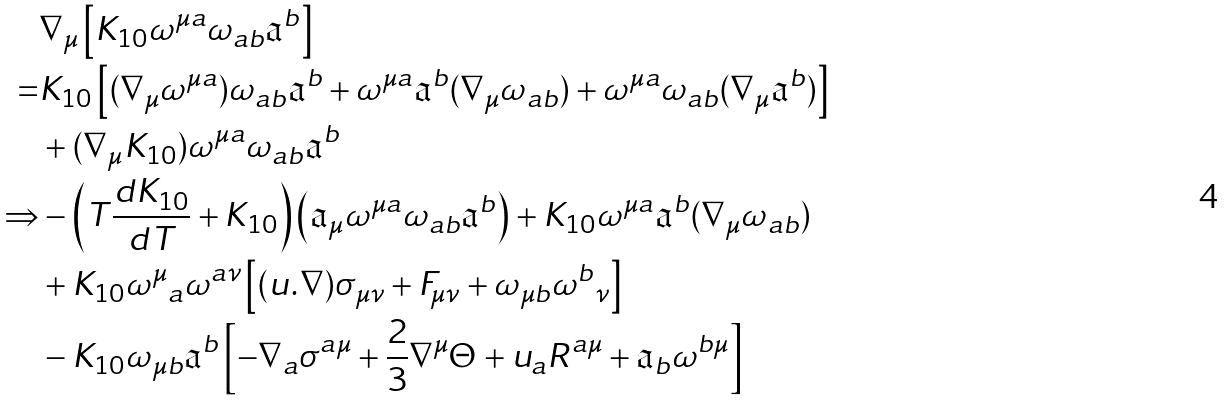<formula> <loc_0><loc_0><loc_500><loc_500>& \nabla _ { \mu } \left [ K _ { 1 0 } \omega ^ { \mu a } \omega _ { a b } { \mathfrak a } ^ { b } \right ] \\ = & K _ { 1 0 } \left [ ( \nabla _ { \mu } \omega ^ { \mu a } ) \omega _ { a b } { \mathfrak a } ^ { b } + \omega ^ { \mu a } { \mathfrak a } ^ { b } ( \nabla _ { \mu } \omega _ { a b } ) + \omega ^ { \mu a } \omega _ { a b } ( \nabla _ { \mu } { \mathfrak a } ^ { b } ) \right ] \\ & + ( \nabla _ { \mu } K _ { 1 0 } ) \omega ^ { \mu a } \omega _ { a b } { \mathfrak a } ^ { b } \\ \Rightarrow & - \left ( T \frac { d K _ { 1 0 } } { d T } + K _ { 1 0 } \right ) \left ( { \mathfrak a } _ { \mu } \omega ^ { \mu a } \omega _ { a b } { \mathfrak a } ^ { b } \right ) + K _ { 1 0 } \omega ^ { \mu a } { \mathfrak a } ^ { b } ( \nabla _ { \mu } \omega _ { a b } ) \\ & + K _ { 1 0 } { \omega ^ { \mu } } _ { a } \omega ^ { a \nu } \left [ ( u . \nabla ) \sigma _ { \mu \nu } + F _ { \mu \nu } + \omega _ { \mu b } { \omega ^ { b } } _ { \nu } \right ] \\ & - K _ { 1 0 } \omega _ { \mu b } { \mathfrak a } ^ { b } \left [ - \nabla _ { a } \sigma ^ { a \mu } + \frac { 2 } { 3 } \nabla ^ { \mu } \Theta + u _ { a } R ^ { a \mu } + { \mathfrak a } _ { b } \omega ^ { b \mu } \right ] \\</formula> 